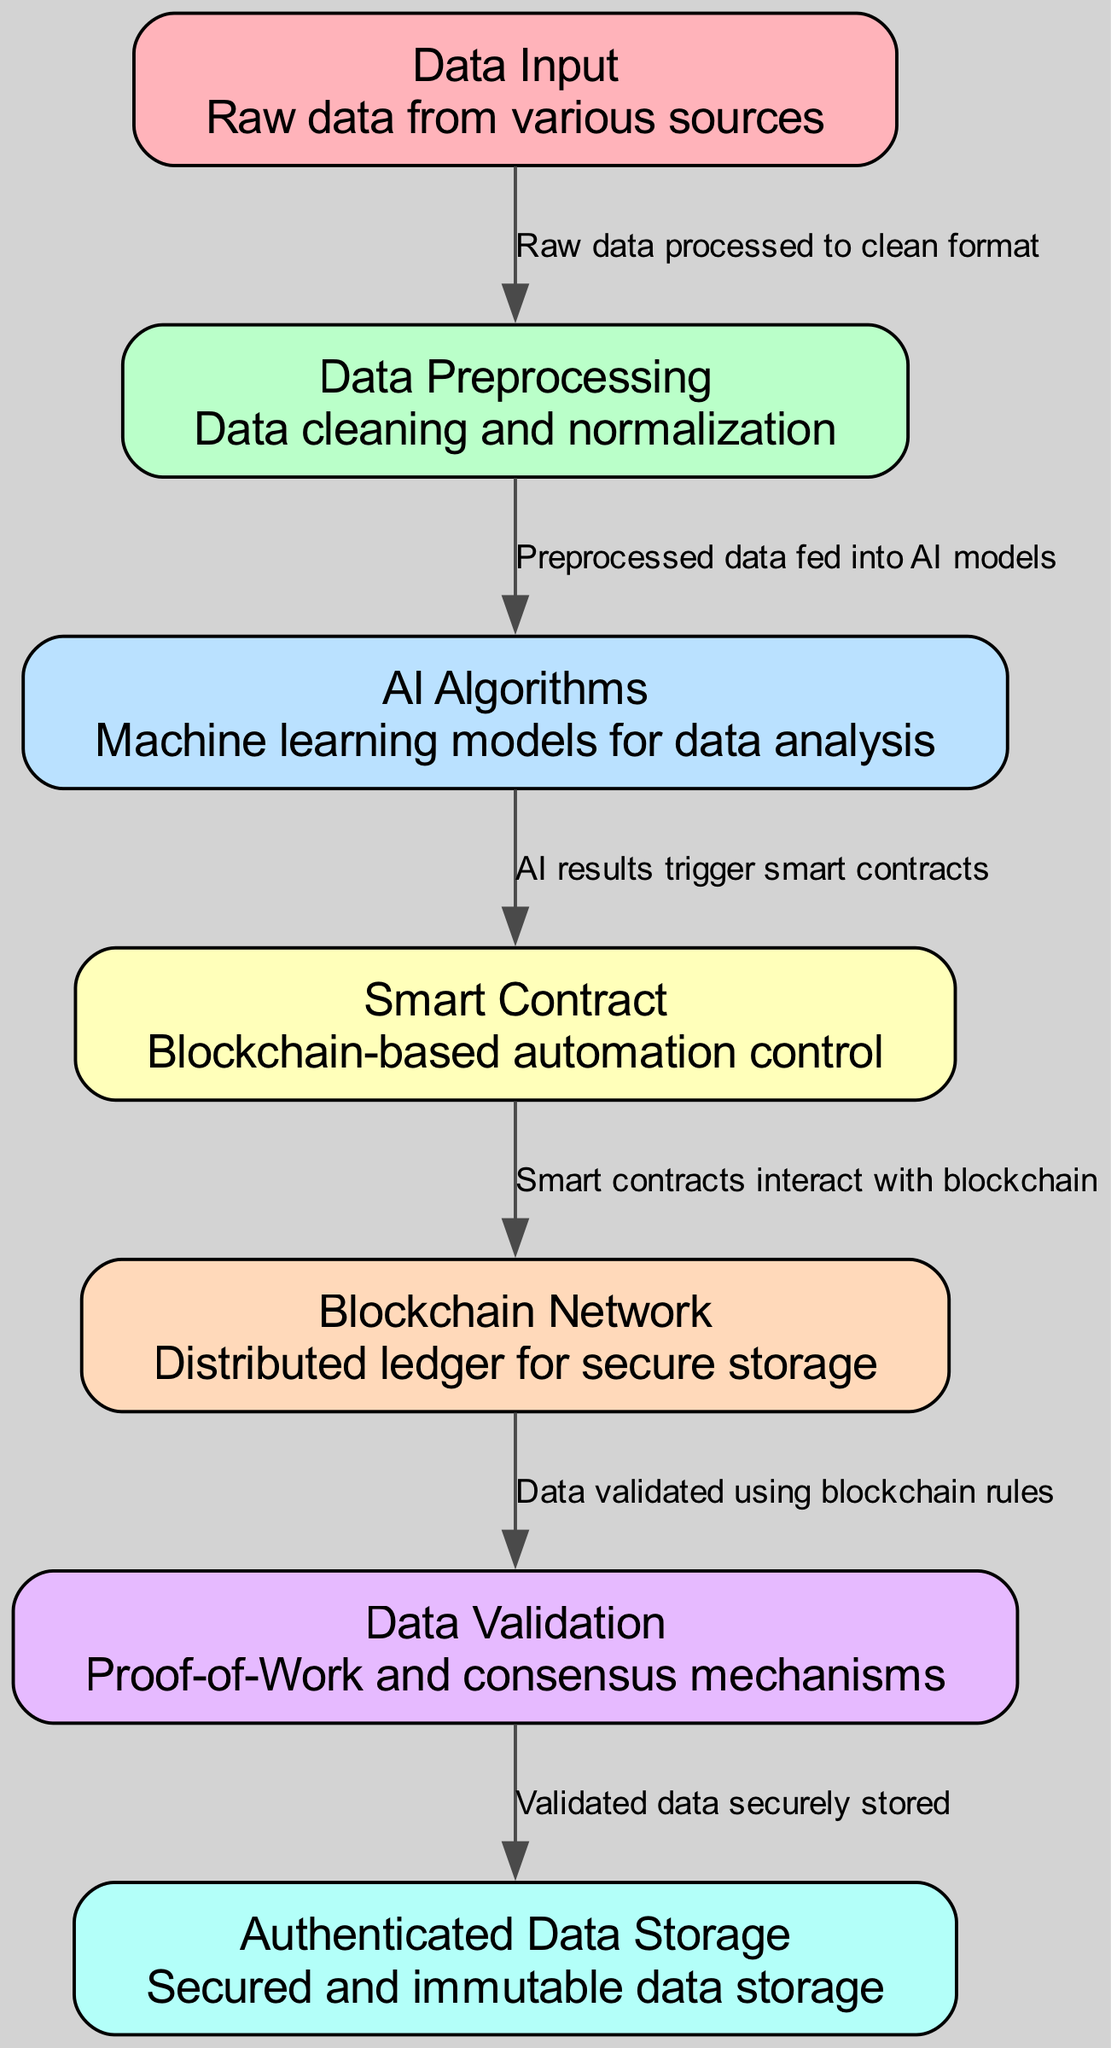What is the first step in the workflow? The first step indicated in the workflow diagram is "Data Input." It shows that this step involves raw data collected from various sources.
Answer: Data Input How many nodes are in the diagram? By counting all the unique elements depicted as nodes in the diagram, we find there are seven nodes total, each representing a different stage in the workflow.
Answer: 7 What does the "Data Preprocessing" step entail? The "Data Preprocessing" node describes the process of cleaning and normalizing the raw data before it is analyzed further, which is vital for ensuring the quality of the data used in subsequent steps.
Answer: Data cleaning and normalization Which node does "AI Algorithms" output trigger? The flow from "AI Algorithms" indicates that the output of this step triggers the "Smart Contract," which automates further operations based on the results from the AI analysis.
Answer: Smart Contract What is the relationship between "Blockchain Network" and "Data Validation"? The edge connecting "Blockchain Network" and "Data Validation" indicates that the data is validated through specific rules governed by the blockchain, ensuring that only legitimate data is processed.
Answer: Data validated using blockchain rules How many edges are in the diagram? Each connection between nodes represents an edge in the diagram. There are six edges connecting the seven nodes, indicating the workflow's sequential dependencies.
Answer: 6 What is stored in the "Authenticated Data Storage"? The "Authenticated Data Storage" represents the final step where data that has been validated throughout the previous processes is kept secure and immutable, ensuring its integrity over time.
Answer: Secured and immutable data storage What role do smart contracts play in this workflow? Smart contracts act as automated control mechanisms that facilitate specific actions or agreements based on the outcomes produced by the AI algorithms, playing a crucial role in the workflow's automation.
Answer: Blockchain-based automation control What is the significance of "Proof-of-Work" in the diagram? "Proof-of-Work" is highlighted in the "Data Validation" node as a consensus mechanism used to verify the integrity of the data stored on the blockchain, ensuring that all parties agree on the validity of the data.
Answer: Proof-of-Work and consensus mechanisms 